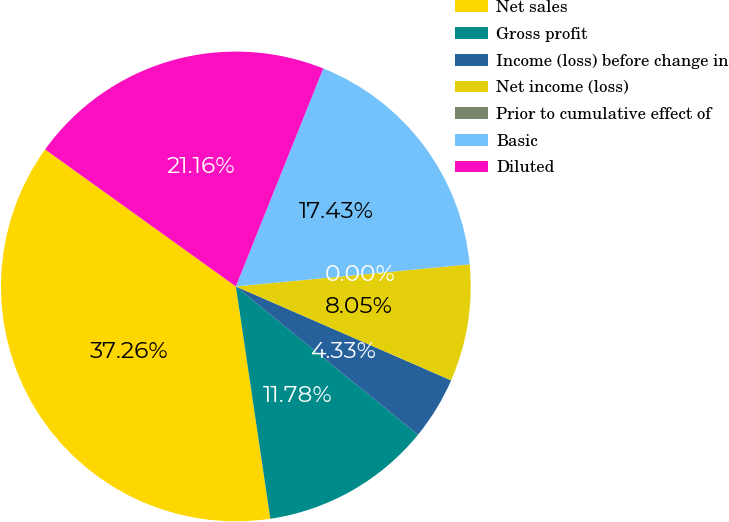<chart> <loc_0><loc_0><loc_500><loc_500><pie_chart><fcel>Net sales<fcel>Gross profit<fcel>Income (loss) before change in<fcel>Net income (loss)<fcel>Prior to cumulative effect of<fcel>Basic<fcel>Diluted<nl><fcel>37.26%<fcel>11.78%<fcel>4.33%<fcel>8.05%<fcel>0.0%<fcel>17.43%<fcel>21.16%<nl></chart> 